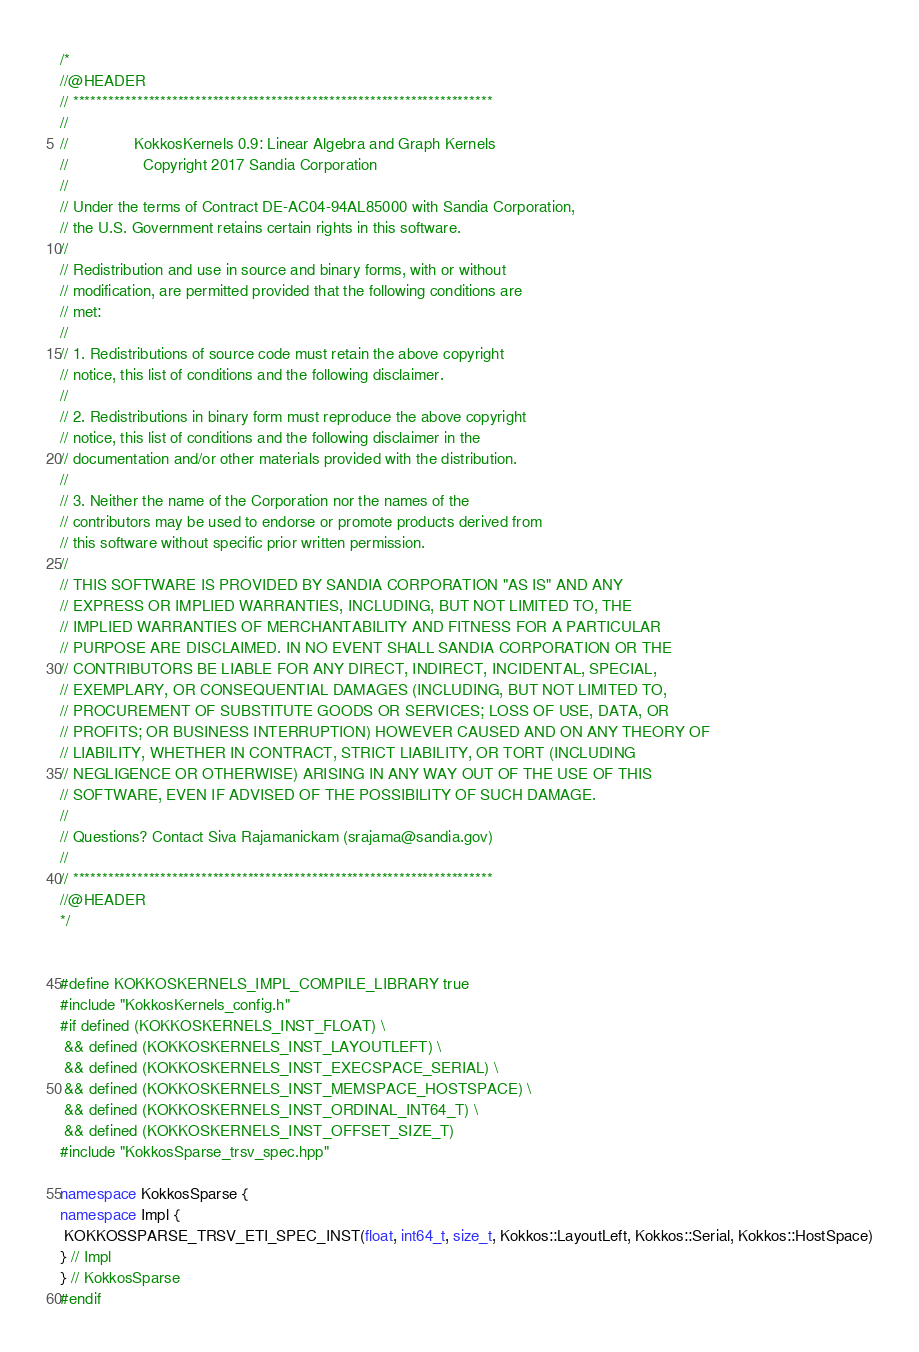Convert code to text. <code><loc_0><loc_0><loc_500><loc_500><_C++_>/*
//@HEADER
// ************************************************************************
//
//               KokkosKernels 0.9: Linear Algebra and Graph Kernels
//                 Copyright 2017 Sandia Corporation
//
// Under the terms of Contract DE-AC04-94AL85000 with Sandia Corporation,
// the U.S. Government retains certain rights in this software.
//
// Redistribution and use in source and binary forms, with or without
// modification, are permitted provided that the following conditions are
// met:
//
// 1. Redistributions of source code must retain the above copyright
// notice, this list of conditions and the following disclaimer.
//
// 2. Redistributions in binary form must reproduce the above copyright
// notice, this list of conditions and the following disclaimer in the
// documentation and/or other materials provided with the distribution.
//
// 3. Neither the name of the Corporation nor the names of the
// contributors may be used to endorse or promote products derived from
// this software without specific prior written permission.
//
// THIS SOFTWARE IS PROVIDED BY SANDIA CORPORATION "AS IS" AND ANY
// EXPRESS OR IMPLIED WARRANTIES, INCLUDING, BUT NOT LIMITED TO, THE
// IMPLIED WARRANTIES OF MERCHANTABILITY AND FITNESS FOR A PARTICULAR
// PURPOSE ARE DISCLAIMED. IN NO EVENT SHALL SANDIA CORPORATION OR THE
// CONTRIBUTORS BE LIABLE FOR ANY DIRECT, INDIRECT, INCIDENTAL, SPECIAL,
// EXEMPLARY, OR CONSEQUENTIAL DAMAGES (INCLUDING, BUT NOT LIMITED TO,
// PROCUREMENT OF SUBSTITUTE GOODS OR SERVICES; LOSS OF USE, DATA, OR
// PROFITS; OR BUSINESS INTERRUPTION) HOWEVER CAUSED AND ON ANY THEORY OF
// LIABILITY, WHETHER IN CONTRACT, STRICT LIABILITY, OR TORT (INCLUDING
// NEGLIGENCE OR OTHERWISE) ARISING IN ANY WAY OUT OF THE USE OF THIS
// SOFTWARE, EVEN IF ADVISED OF THE POSSIBILITY OF SUCH DAMAGE.
//
// Questions? Contact Siva Rajamanickam (srajama@sandia.gov)
//
// ************************************************************************
//@HEADER
*/


#define KOKKOSKERNELS_IMPL_COMPILE_LIBRARY true
#include "KokkosKernels_config.h"
#if defined (KOKKOSKERNELS_INST_FLOAT) \
 && defined (KOKKOSKERNELS_INST_LAYOUTLEFT) \
 && defined (KOKKOSKERNELS_INST_EXECSPACE_SERIAL) \
 && defined (KOKKOSKERNELS_INST_MEMSPACE_HOSTSPACE) \
 && defined (KOKKOSKERNELS_INST_ORDINAL_INT64_T) \
 && defined (KOKKOSKERNELS_INST_OFFSET_SIZE_T) 
#include "KokkosSparse_trsv_spec.hpp"

namespace KokkosSparse {
namespace Impl {
 KOKKOSSPARSE_TRSV_ETI_SPEC_INST(float, int64_t, size_t, Kokkos::LayoutLeft, Kokkos::Serial, Kokkos::HostSpace)
} // Impl
} // KokkosSparse
#endif
</code> 